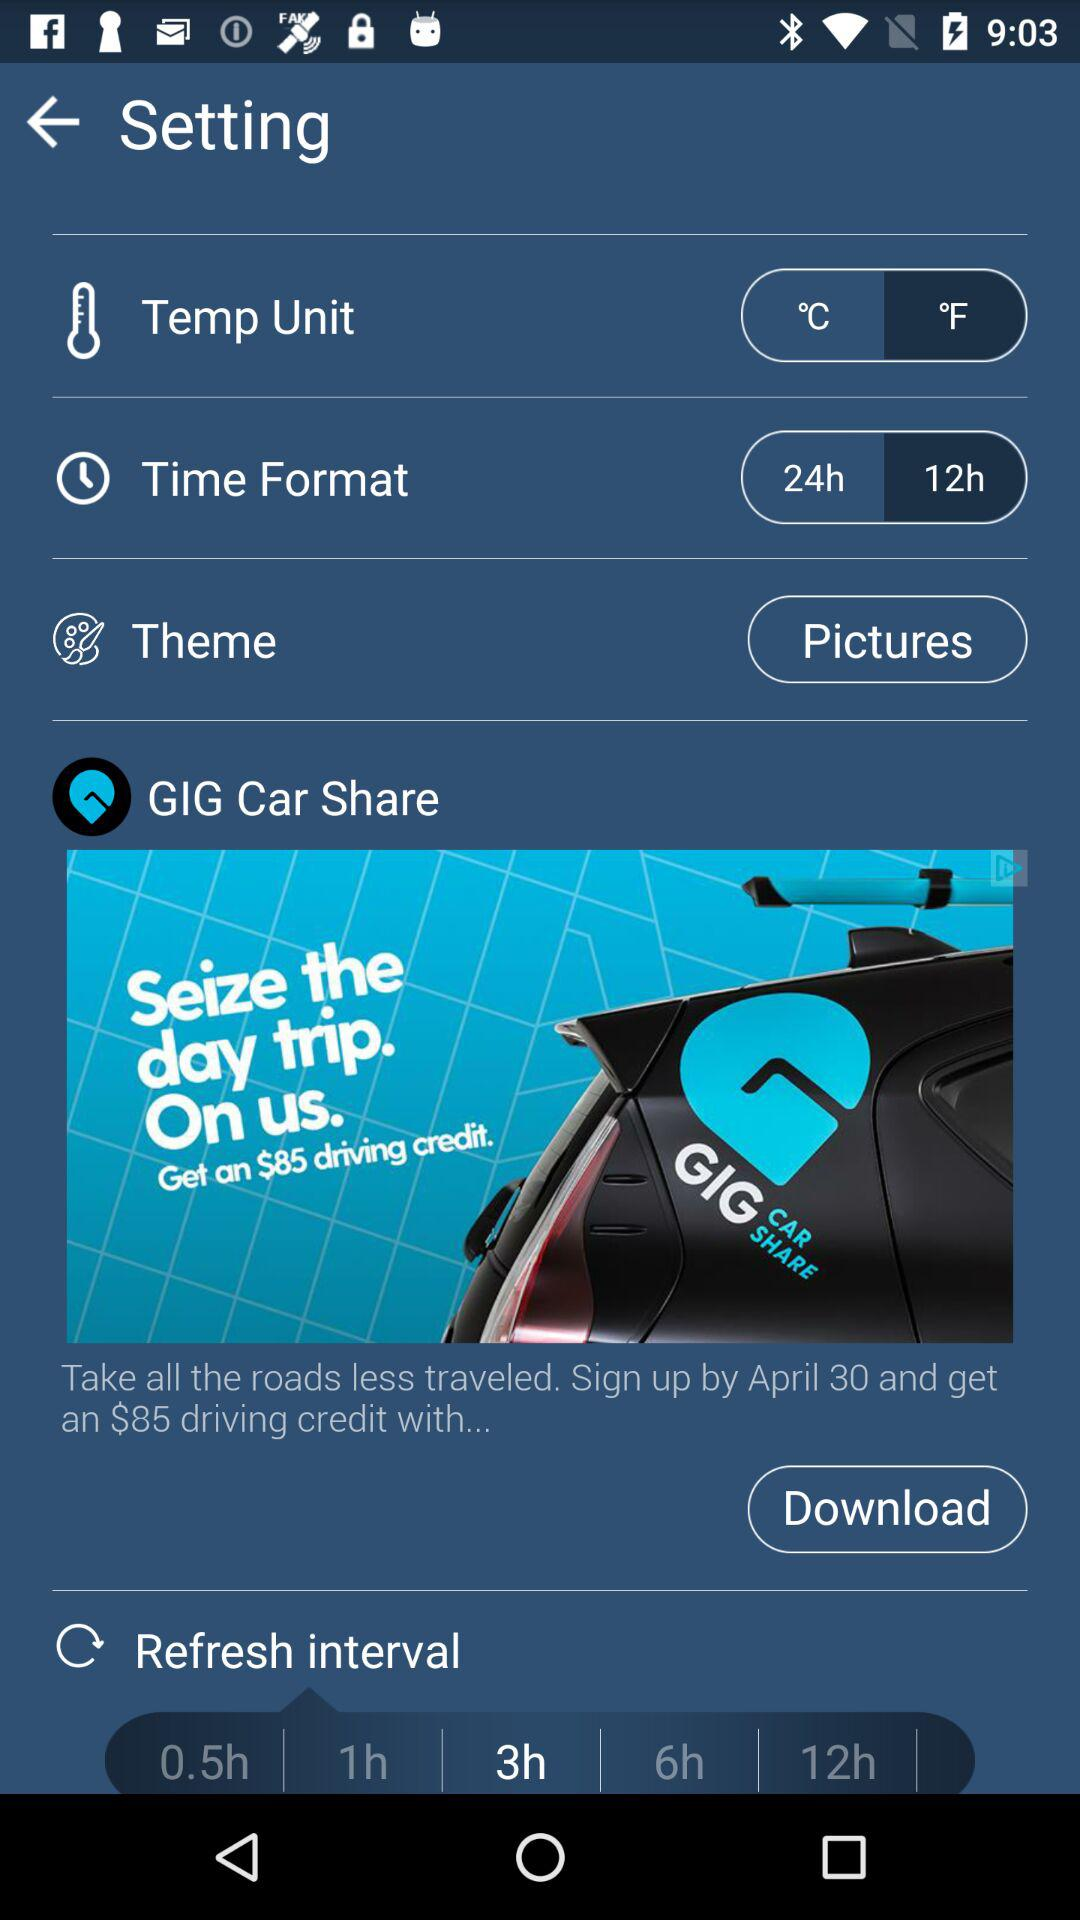What is the setting for "Temp Unit"? The setting is "°F". 